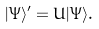Convert formula to latex. <formula><loc_0><loc_0><loc_500><loc_500>| \Psi \rangle ^ { \prime } = U | \Psi \rangle .</formula> 